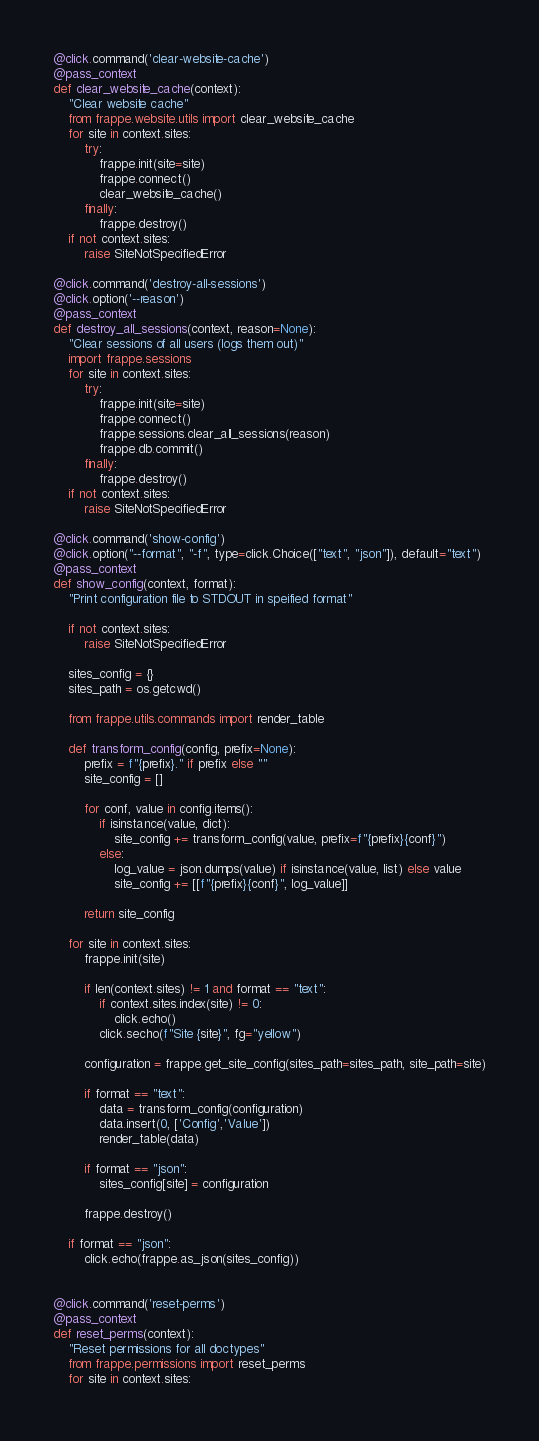<code> <loc_0><loc_0><loc_500><loc_500><_Python_>
@click.command('clear-website-cache')
@pass_context
def clear_website_cache(context):
	"Clear website cache"
	from frappe.website.utils import clear_website_cache
	for site in context.sites:
		try:
			frappe.init(site=site)
			frappe.connect()
			clear_website_cache()
		finally:
			frappe.destroy()
	if not context.sites:
		raise SiteNotSpecifiedError

@click.command('destroy-all-sessions')
@click.option('--reason')
@pass_context
def destroy_all_sessions(context, reason=None):
	"Clear sessions of all users (logs them out)"
	import frappe.sessions
	for site in context.sites:
		try:
			frappe.init(site=site)
			frappe.connect()
			frappe.sessions.clear_all_sessions(reason)
			frappe.db.commit()
		finally:
			frappe.destroy()
	if not context.sites:
		raise SiteNotSpecifiedError

@click.command('show-config')
@click.option("--format", "-f", type=click.Choice(["text", "json"]), default="text")
@pass_context
def show_config(context, format):
	"Print configuration file to STDOUT in speified format"

	if not context.sites:
		raise SiteNotSpecifiedError

	sites_config = {}
	sites_path = os.getcwd()

	from frappe.utils.commands import render_table

	def transform_config(config, prefix=None):
		prefix = f"{prefix}." if prefix else ""
		site_config = []

		for conf, value in config.items():
			if isinstance(value, dict):
				site_config += transform_config(value, prefix=f"{prefix}{conf}")
			else:
				log_value = json.dumps(value) if isinstance(value, list) else value
				site_config += [[f"{prefix}{conf}", log_value]]

		return site_config

	for site in context.sites:
		frappe.init(site)

		if len(context.sites) != 1 and format == "text":
			if context.sites.index(site) != 0:
				click.echo()
			click.secho(f"Site {site}", fg="yellow")

		configuration = frappe.get_site_config(sites_path=sites_path, site_path=site)

		if format == "text":
			data = transform_config(configuration)
			data.insert(0, ['Config','Value'])
			render_table(data)

		if format == "json":
			sites_config[site] = configuration

		frappe.destroy()

	if format == "json":
		click.echo(frappe.as_json(sites_config))


@click.command('reset-perms')
@pass_context
def reset_perms(context):
	"Reset permissions for all doctypes"
	from frappe.permissions import reset_perms
	for site in context.sites:</code> 